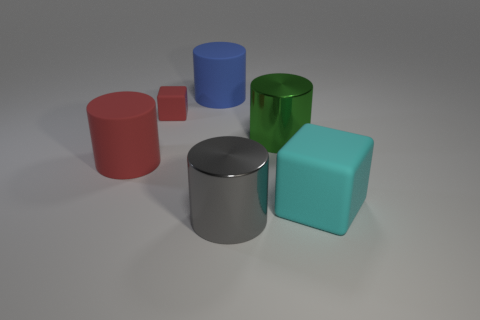Subtract 1 cylinders. How many cylinders are left? 3 Subtract all green cylinders. How many cylinders are left? 3 Subtract all cyan cylinders. Subtract all blue blocks. How many cylinders are left? 4 Add 4 big gray shiny things. How many objects exist? 10 Subtract all cubes. How many objects are left? 4 Add 3 large green cylinders. How many large green cylinders are left? 4 Add 5 big green cylinders. How many big green cylinders exist? 6 Subtract 1 red blocks. How many objects are left? 5 Subtract all cyan rubber cubes. Subtract all small matte objects. How many objects are left? 4 